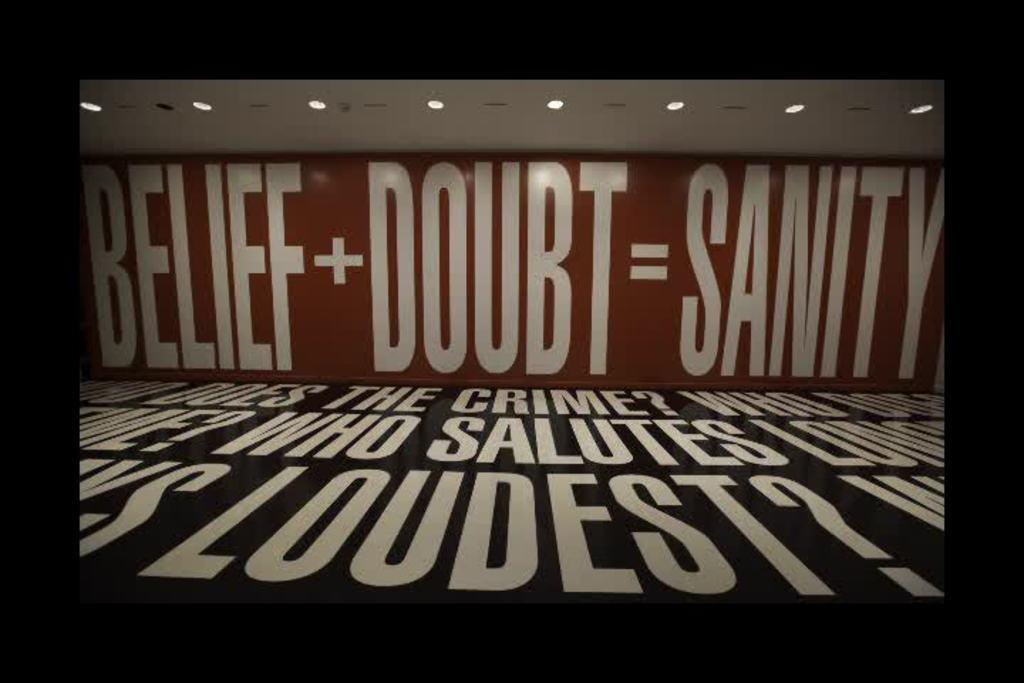<image>
Write a terse but informative summary of the picture. The sign has wording on it that says BELIEF + DOUBT = SANITY. 